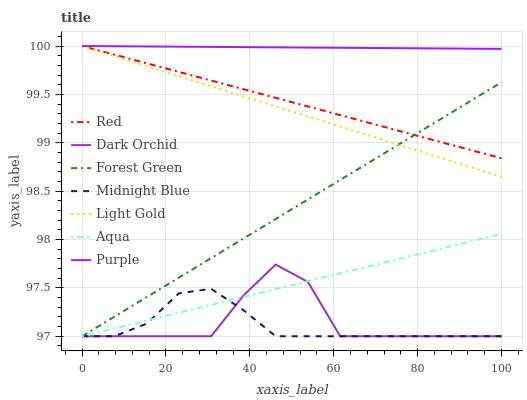Does Midnight Blue have the minimum area under the curve?
Answer yes or no. Yes. Does Purple have the maximum area under the curve?
Answer yes or no. Yes. Does Aqua have the minimum area under the curve?
Answer yes or no. No. Does Aqua have the maximum area under the curve?
Answer yes or no. No. Is Aqua the smoothest?
Answer yes or no. Yes. Is Dark Orchid the roughest?
Answer yes or no. Yes. Is Purple the smoothest?
Answer yes or no. No. Is Purple the roughest?
Answer yes or no. No. Does Midnight Blue have the lowest value?
Answer yes or no. Yes. Does Purple have the lowest value?
Answer yes or no. No. Does Red have the highest value?
Answer yes or no. Yes. Does Aqua have the highest value?
Answer yes or no. No. Is Aqua less than Purple?
Answer yes or no. Yes. Is Light Gold greater than Aqua?
Answer yes or no. Yes. Does Light Gold intersect Forest Green?
Answer yes or no. Yes. Is Light Gold less than Forest Green?
Answer yes or no. No. Is Light Gold greater than Forest Green?
Answer yes or no. No. Does Aqua intersect Purple?
Answer yes or no. No. 